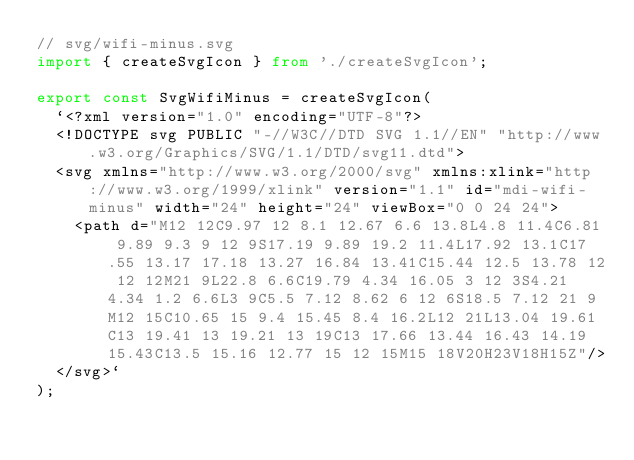<code> <loc_0><loc_0><loc_500><loc_500><_TypeScript_>// svg/wifi-minus.svg
import { createSvgIcon } from './createSvgIcon';

export const SvgWifiMinus = createSvgIcon(
  `<?xml version="1.0" encoding="UTF-8"?>
  <!DOCTYPE svg PUBLIC "-//W3C//DTD SVG 1.1//EN" "http://www.w3.org/Graphics/SVG/1.1/DTD/svg11.dtd">
  <svg xmlns="http://www.w3.org/2000/svg" xmlns:xlink="http://www.w3.org/1999/xlink" version="1.1" id="mdi-wifi-minus" width="24" height="24" viewBox="0 0 24 24">
    <path d="M12 12C9.97 12 8.1 12.67 6.6 13.8L4.8 11.4C6.81 9.89 9.3 9 12 9S17.19 9.89 19.2 11.4L17.92 13.1C17.55 13.17 17.18 13.27 16.84 13.41C15.44 12.5 13.78 12 12 12M21 9L22.8 6.6C19.79 4.34 16.05 3 12 3S4.21 4.34 1.2 6.6L3 9C5.5 7.12 8.62 6 12 6S18.5 7.12 21 9M12 15C10.65 15 9.4 15.45 8.4 16.2L12 21L13.04 19.61C13 19.41 13 19.21 13 19C13 17.66 13.44 16.43 14.19 15.43C13.5 15.16 12.77 15 12 15M15 18V20H23V18H15Z"/>
  </svg>`
);

</code> 